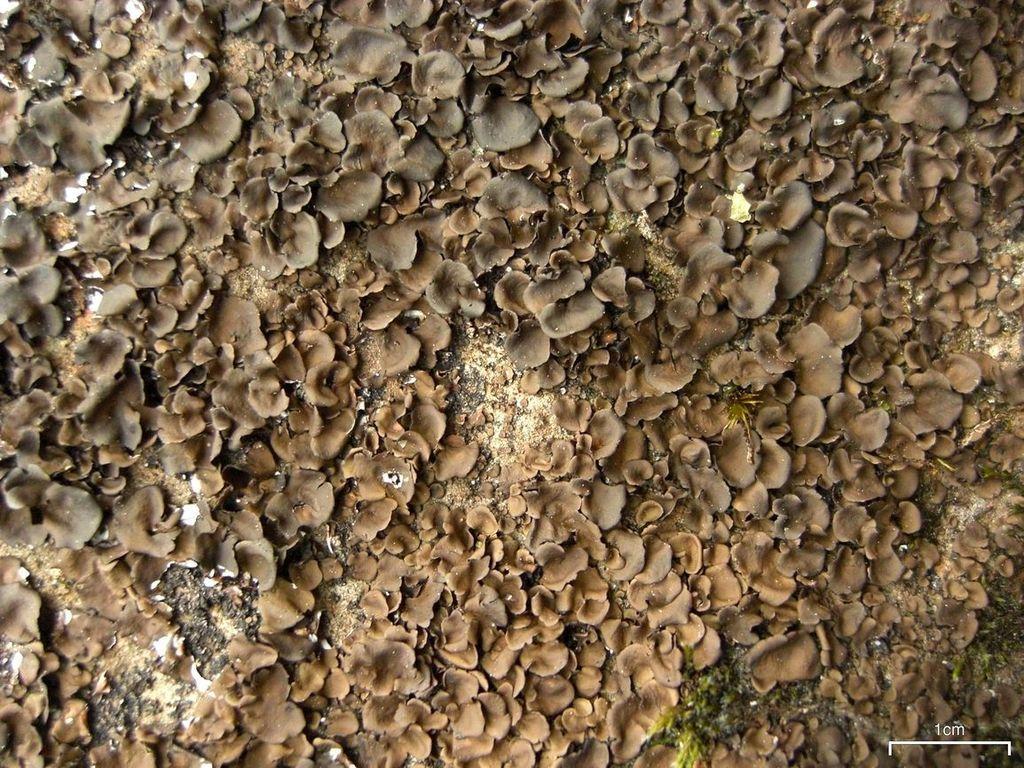Could you give a brief overview of what you see in this image? In this image we can see planets on the ground. 